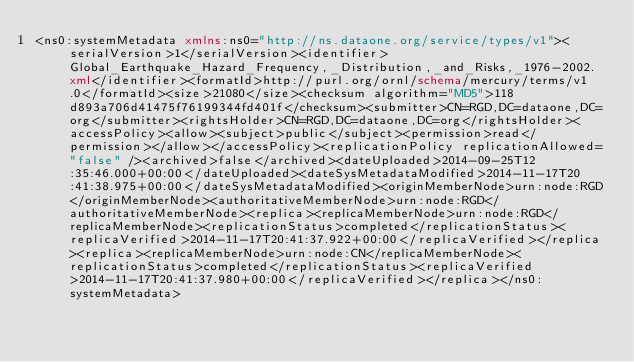Convert code to text. <code><loc_0><loc_0><loc_500><loc_500><_XML_><ns0:systemMetadata xmlns:ns0="http://ns.dataone.org/service/types/v1"><serialVersion>1</serialVersion><identifier>Global_Earthquake_Hazard_Frequency,_Distribution,_and_Risks,_1976-2002.xml</identifier><formatId>http://purl.org/ornl/schema/mercury/terms/v1.0</formatId><size>21080</size><checksum algorithm="MD5">118d893a706d41475f76199344fd401f</checksum><submitter>CN=RGD,DC=dataone,DC=org</submitter><rightsHolder>CN=RGD,DC=dataone,DC=org</rightsHolder><accessPolicy><allow><subject>public</subject><permission>read</permission></allow></accessPolicy><replicationPolicy replicationAllowed="false" /><archived>false</archived><dateUploaded>2014-09-25T12:35:46.000+00:00</dateUploaded><dateSysMetadataModified>2014-11-17T20:41:38.975+00:00</dateSysMetadataModified><originMemberNode>urn:node:RGD</originMemberNode><authoritativeMemberNode>urn:node:RGD</authoritativeMemberNode><replica><replicaMemberNode>urn:node:RGD</replicaMemberNode><replicationStatus>completed</replicationStatus><replicaVerified>2014-11-17T20:41:37.922+00:00</replicaVerified></replica><replica><replicaMemberNode>urn:node:CN</replicaMemberNode><replicationStatus>completed</replicationStatus><replicaVerified>2014-11-17T20:41:37.980+00:00</replicaVerified></replica></ns0:systemMetadata></code> 